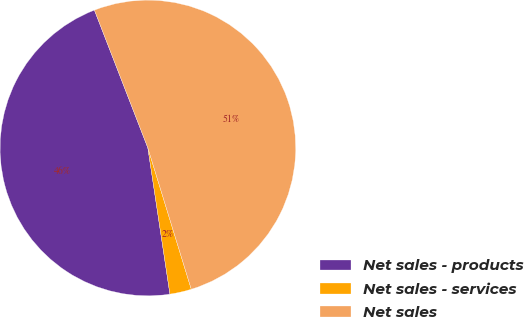<chart> <loc_0><loc_0><loc_500><loc_500><pie_chart><fcel>Net sales - products<fcel>Net sales - services<fcel>Net sales<nl><fcel>46.5%<fcel>2.36%<fcel>51.15%<nl></chart> 